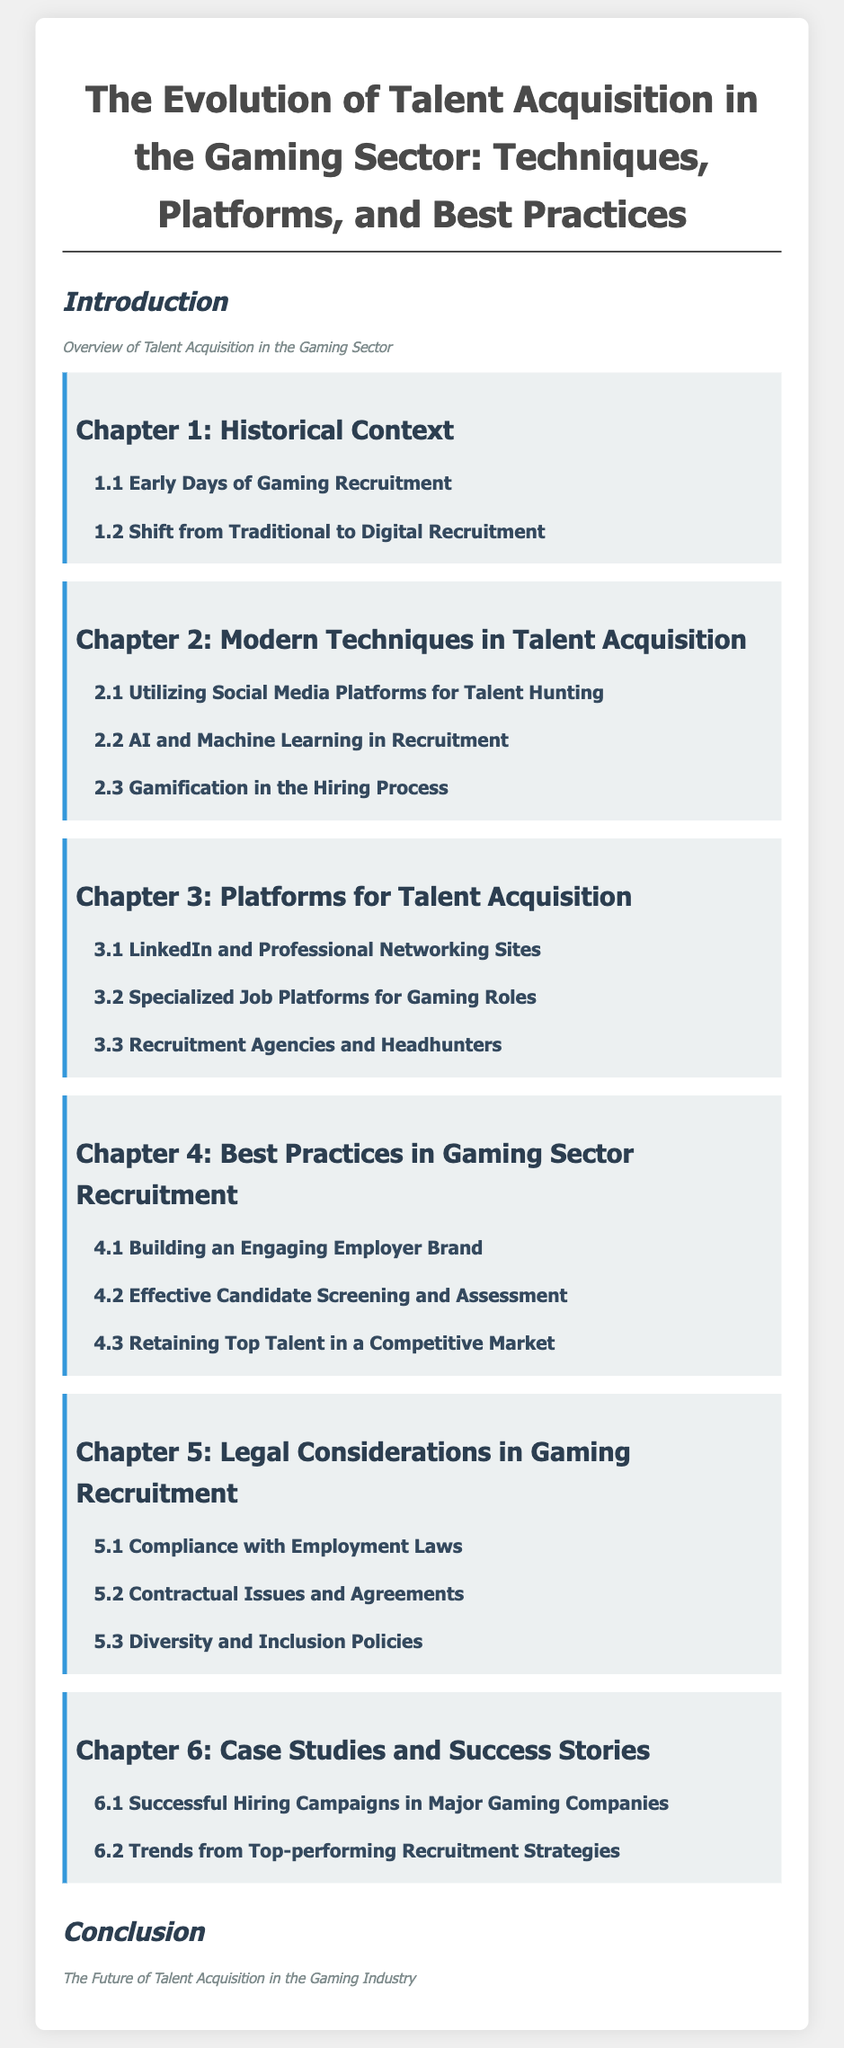What is the title of the document? The title is provided at the top of the document and summarizes the main topic.
Answer: The Evolution of Talent Acquisition in the Gaming Sector: Techniques, Platforms, and Best Practices How many chapters are there in the document? The number of chapters can be counted from the Table of Contents section.
Answer: 6 What is the focus of Chapter 2? The chapter titles indicate that it covers modern techniques in talent acquisition.
Answer: Modern Techniques in Talent Acquisition What is covered under 5.2 in Chapter 5? The specific section titles indicate topics discussed under legal considerations in recruitment.
Answer: Contractual Issues and Agreements Which chapter discusses case studies? The chapter titles indicate that it specifically addresses case studies and success stories.
Answer: Chapter 6 What is the subtitle of Chapter 4? Subtitles are visible in the chapters, indicating best practices in recruitment.
Answer: Best Practices in Gaming Sector Recruitment What is the introduction about? The introductory section summarizes the overall purpose of the document.
Answer: Overview of Talent Acquisition in the Gaming Sector Which section discusses the use of AI in recruitment? The section titles help identify where AI-related techniques in recruitment are discussed.
Answer: 2.2 AI and Machine Learning in Recruitment What does the conclusion suggest about the future? The conclusion contains a statement regarding the future direction of talent acquisition.
Answer: The Future of Talent Acquisition in the Gaming Industry 